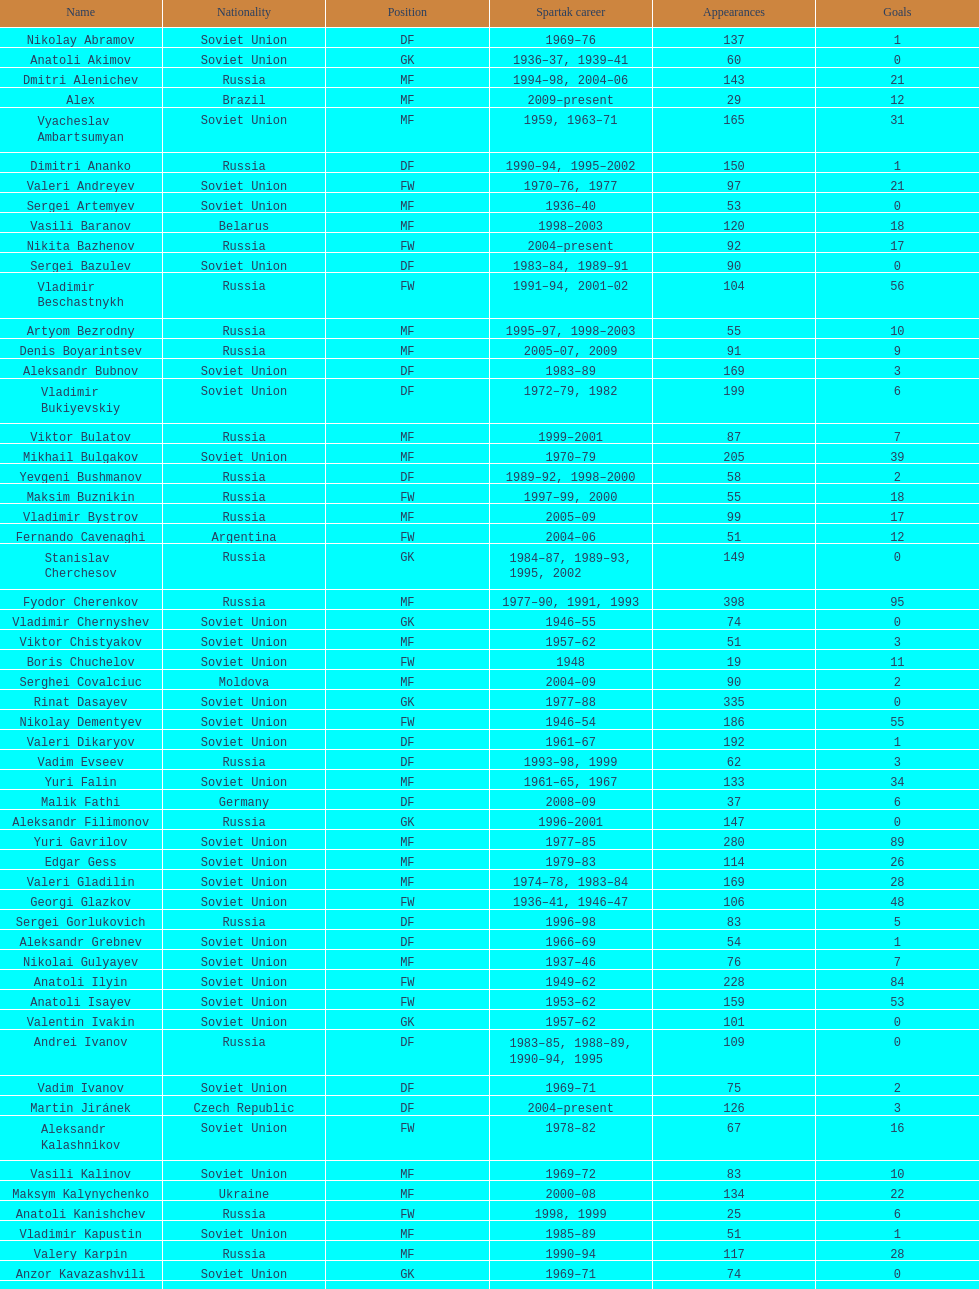Who had the maximum number of appearances? Fyodor Cherenkov. 